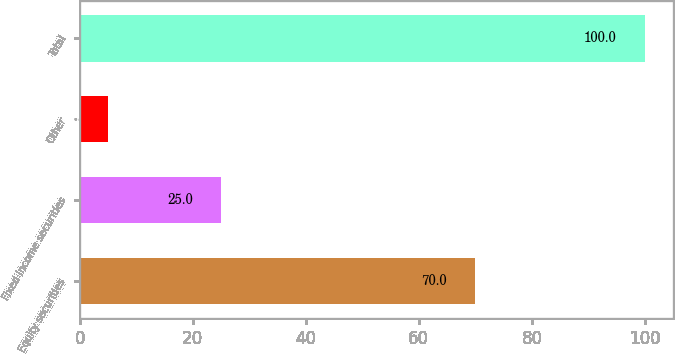Convert chart to OTSL. <chart><loc_0><loc_0><loc_500><loc_500><bar_chart><fcel>Equity securities<fcel>Fixed income securities<fcel>Other<fcel>Total<nl><fcel>70<fcel>25<fcel>5<fcel>100<nl></chart> 